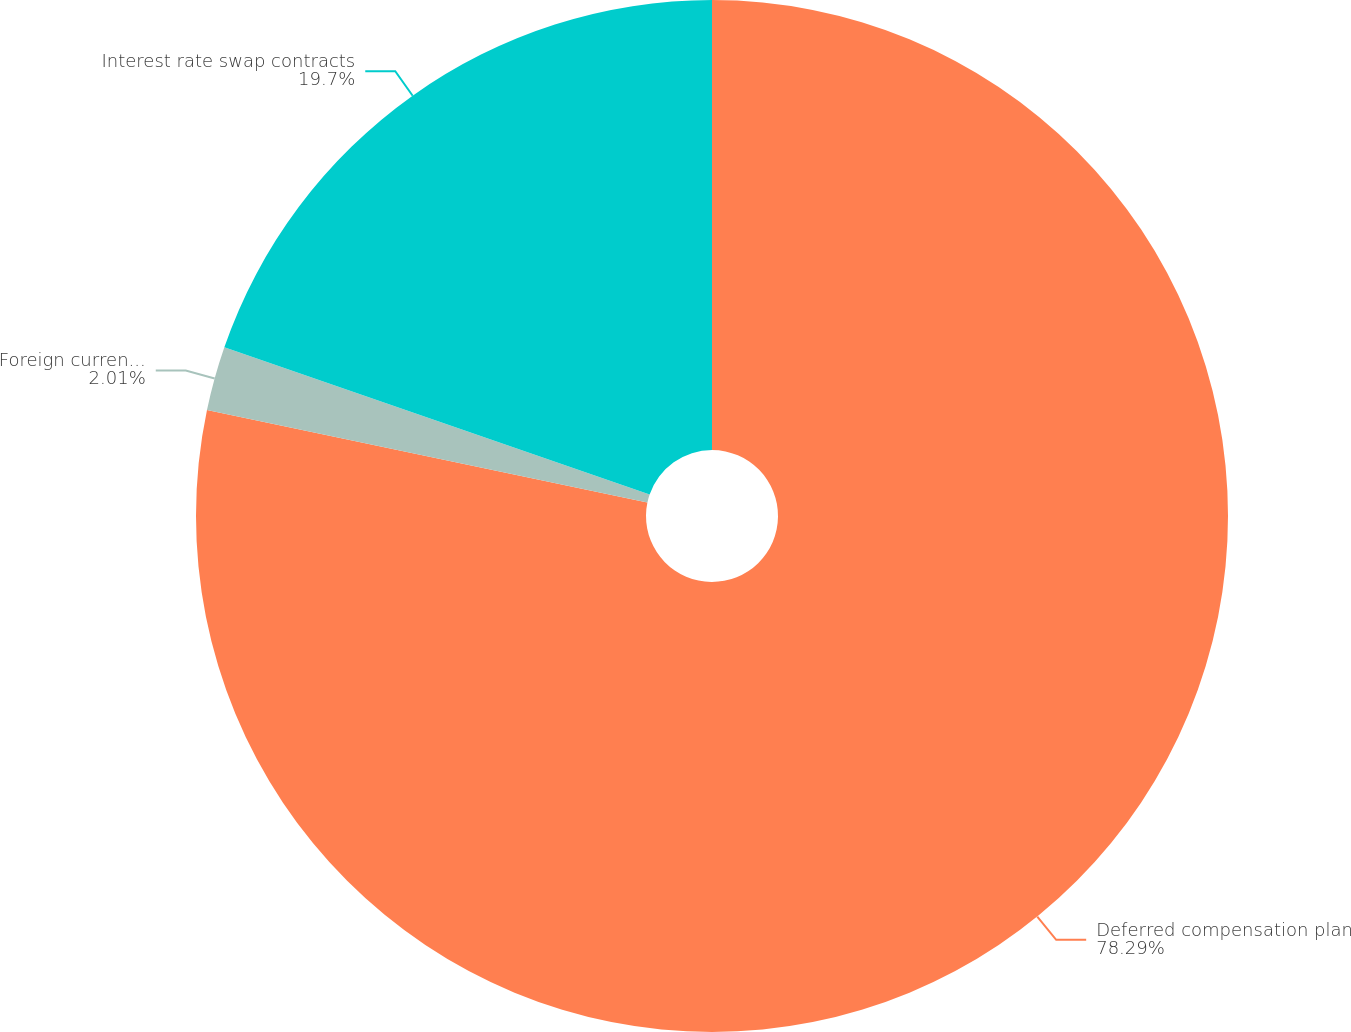Convert chart. <chart><loc_0><loc_0><loc_500><loc_500><pie_chart><fcel>Deferred compensation plan<fcel>Foreign currency forward<fcel>Interest rate swap contracts<nl><fcel>78.29%<fcel>2.01%<fcel>19.7%<nl></chart> 